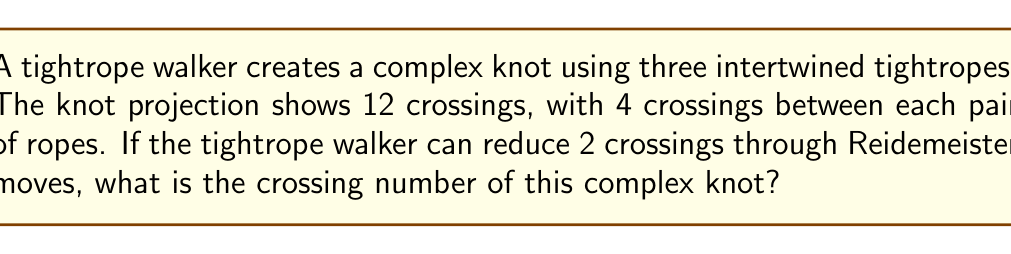Show me your answer to this math problem. Let's approach this step-by-step:

1) First, we need to understand what the crossing number represents. The crossing number of a knot is the minimum number of crossings that occur in any projection of the knot.

2) We're given that the initial projection shows 12 crossings. This can be represented as:

   $$\text{Initial crossings} = 12$$

3) We're also told that there are 4 crossings between each pair of ropes. With three ropes, there are three pairs, confirming our total of 12 crossings:

   $$3 \text{ pairs} \times 4 \text{ crossings per pair} = 12 \text{ crossings}$$

4) The tightrope walker can reduce 2 crossings through Reidemeister moves. Reidemeister moves are ways to manipulate a knot diagram without changing the underlying knot. This means:

   $$\text{Reducible crossings} = 2$$

5) To find the crossing number, we subtract the reducible crossings from the initial crossings:

   $$\text{Crossing number} = \text{Initial crossings} - \text{Reducible crossings}$$
   $$\text{Crossing number} = 12 - 2 = 10$$

Therefore, the crossing number of this complex knot is 10.
Answer: 10 